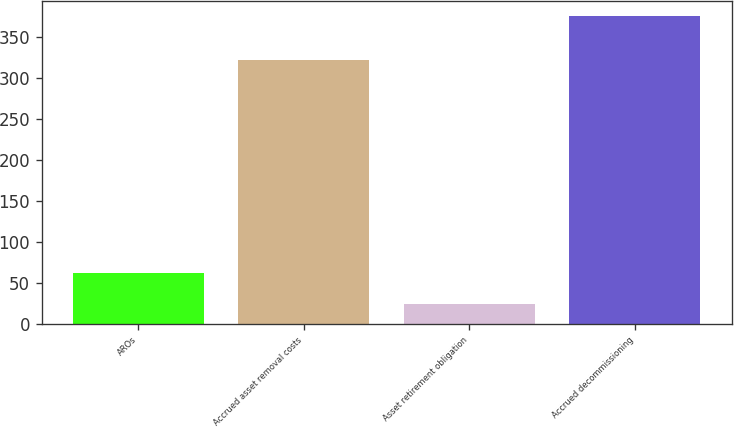<chart> <loc_0><loc_0><loc_500><loc_500><bar_chart><fcel>AROs<fcel>Accrued asset removal costs<fcel>Asset retirement obligation<fcel>Accrued decommissioning<nl><fcel>62<fcel>322<fcel>24<fcel>376<nl></chart> 